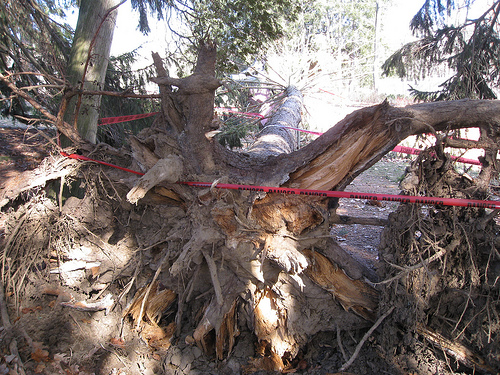<image>
Can you confirm if the tree is on the ground? Yes. Looking at the image, I can see the tree is positioned on top of the ground, with the ground providing support. 